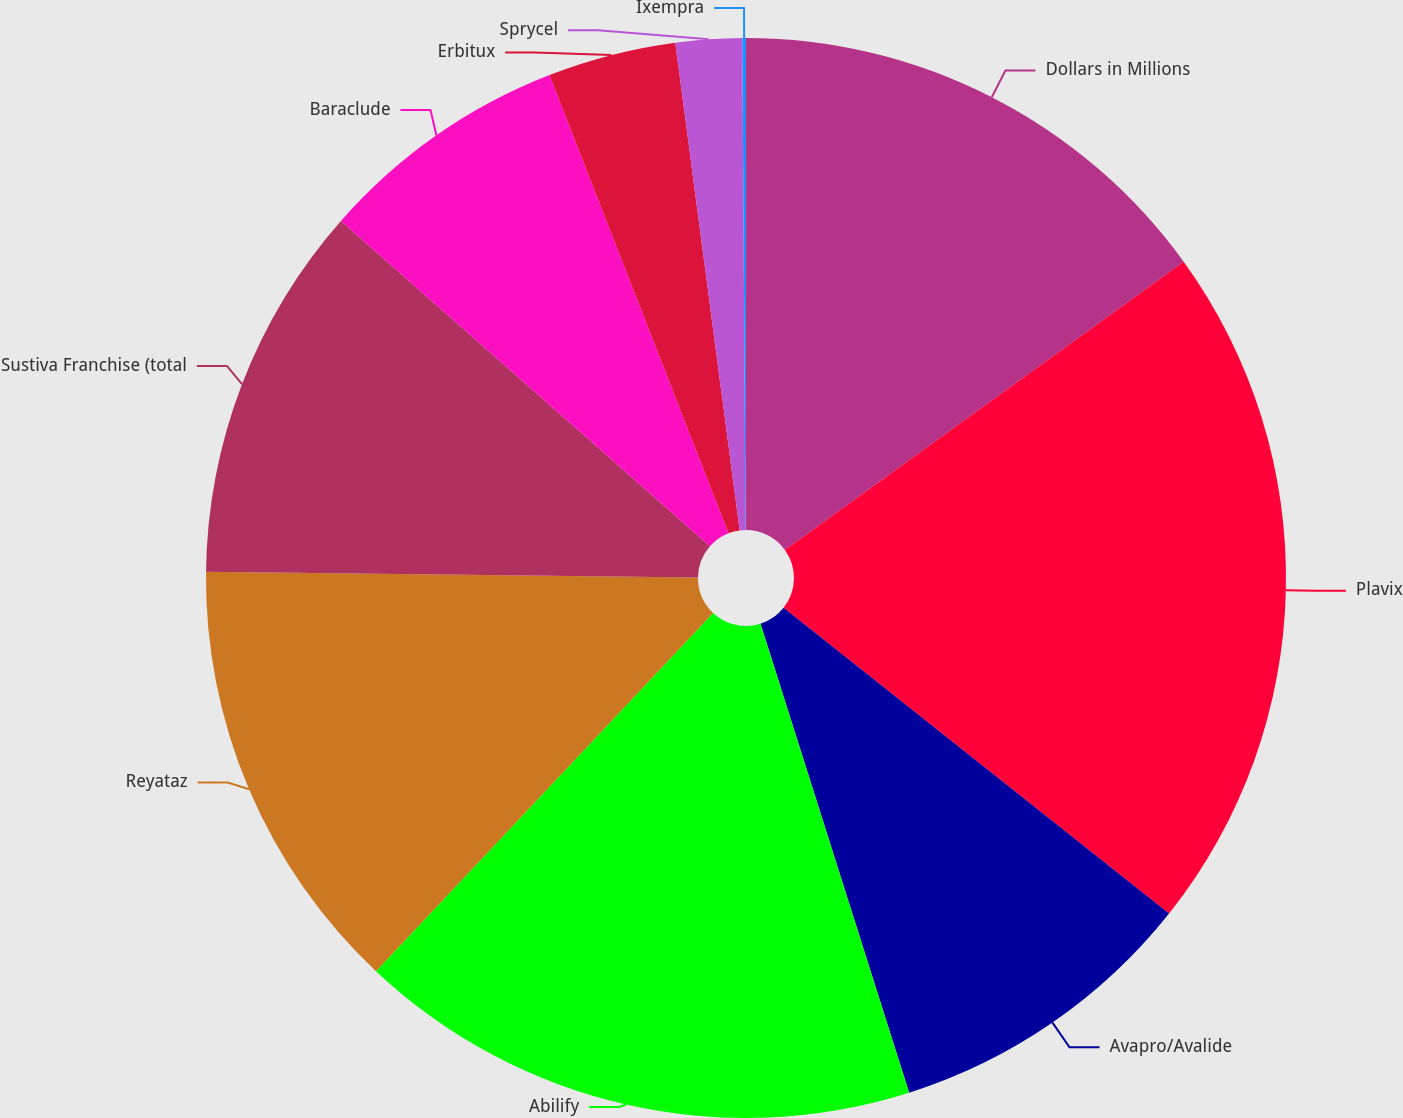Convert chart. <chart><loc_0><loc_0><loc_500><loc_500><pie_chart><fcel>Dollars in Millions<fcel>Plavix<fcel>Avapro/Avalide<fcel>Abilify<fcel>Reyataz<fcel>Sustiva Franchise (total<fcel>Baraclude<fcel>Erbitux<fcel>Sprycel<fcel>Ixempra<nl><fcel>15.04%<fcel>20.63%<fcel>9.44%<fcel>16.9%<fcel>13.17%<fcel>11.31%<fcel>7.57%<fcel>3.84%<fcel>1.98%<fcel>0.11%<nl></chart> 